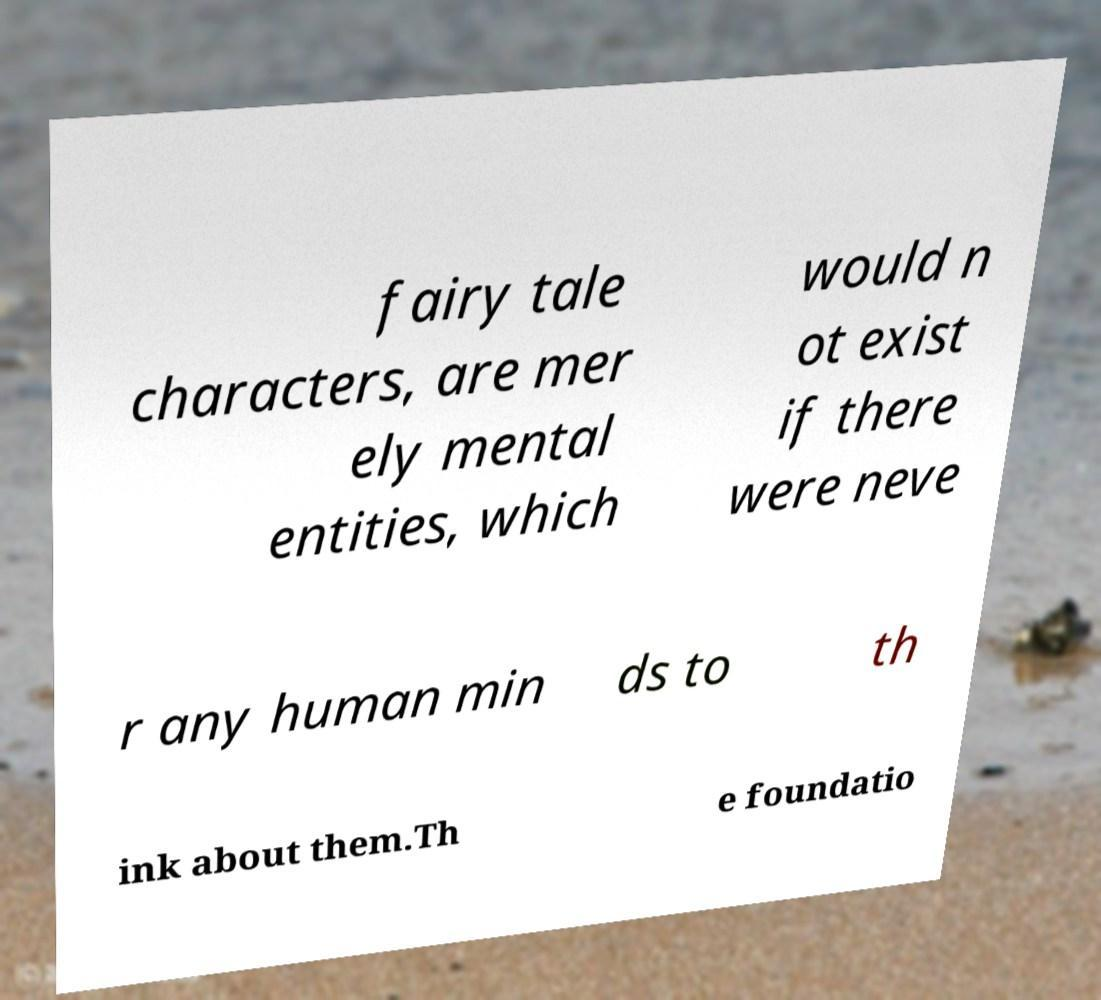For documentation purposes, I need the text within this image transcribed. Could you provide that? fairy tale characters, are mer ely mental entities, which would n ot exist if there were neve r any human min ds to th ink about them.Th e foundatio 